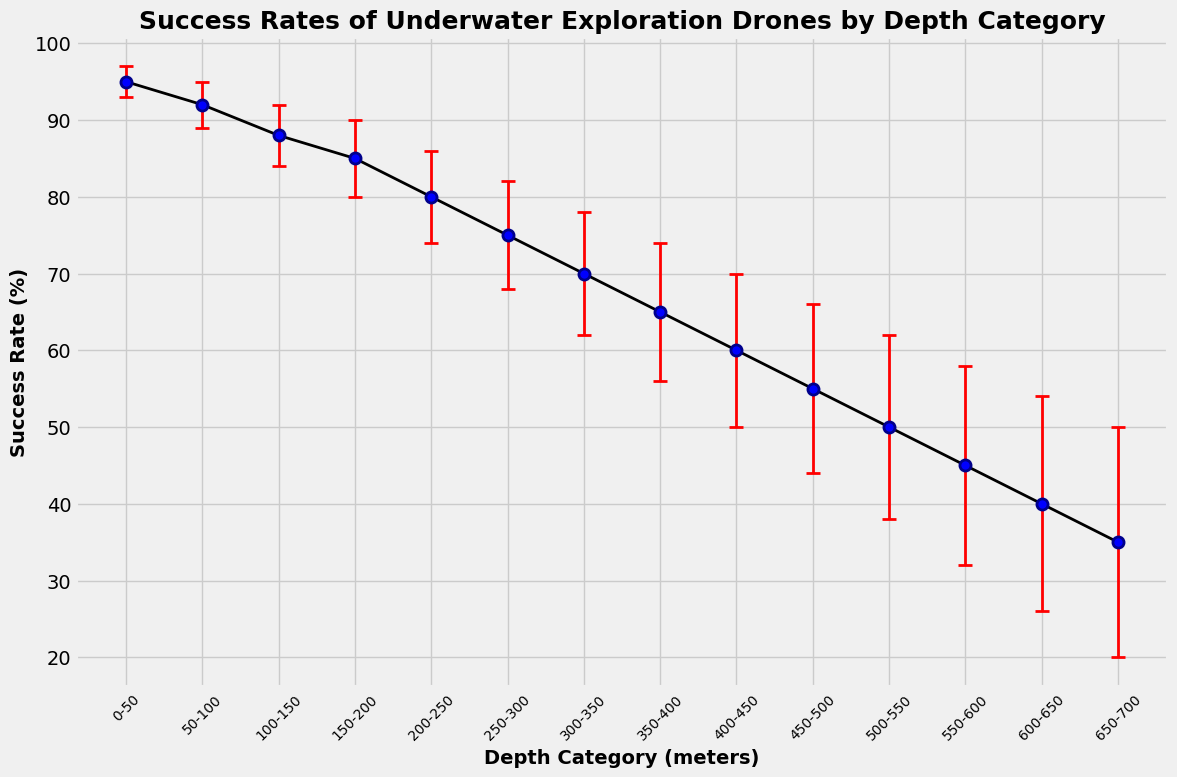What is the highest success rate depicted in the figure? The figure clearly shows the highest success rate at the shallowest depth category of 0-50 meters.
Answer: 95% What is the range of depths where the drone's success rate is between 50% and 60%? From the figure, the success rate is 55% at 450-500 meters and 60% at 400-450 meters, hence this range.
Answer: 400-500 meters Which depth category has the largest error margin, and what is it? By examining the red error bars, the largest error margin is at the 650-700 meters depth category with an error margin of 15%.
Answer: 650-700 meters, 15% How does the success rate change as the depth increases from 0-700 meters? Observing the trend line, the success rate gradually decreases as the depth increases from 95% at 0-50 meters to 35% at 650-700 meters.
Answer: Decreases What is the average success rate for the depth categories 200-300 meters? The success rates for 200-250 meters and 250-300 meters are 80% and 75% respectively. (80+75) / 2 = 77.5%.
Answer: 77.5% How much does the success rate drop from 0-50 meters to 550-600 meters? The success rate at 0-50 meters is 95%, and at 550-600 meters is 45%. The drop is calculated as 95% - 45% = 50%.
Answer: 50% Between which two consecutive depth categories is the largest drop in success rate observed? The largest drop between consecutive categories is between 250-300 meters and 300-350 meters where the success rate drops from 75% to 70%, resulting in a 5% drop.
Answer: 250-300 and 300-350 meters Is there a depth category where the error margin overlaps with an adjacent category's success rate? The error margin for some categories overlaps when the error bars touch the points of adjacent categories; however, there is no explicit depth category where an overlap is vividly indicated beyond visual inspection.
Answer: Yes Compare the success rate at 0-50 meters with the rate at 450-500 meters. How much higher is the success rate at the shallower depth? The success rate at 0-50 meters is 95%, and at 450-500 meters it's 55%. The difference is 95% - 55% = 40%.
Answer: 40% What is the overall trend in the error margins as the depth increases? The error margins increase steadily alongside the depth increase, as shown by gradually longer red error bars from left to right across the figure.
Answer: Increases 